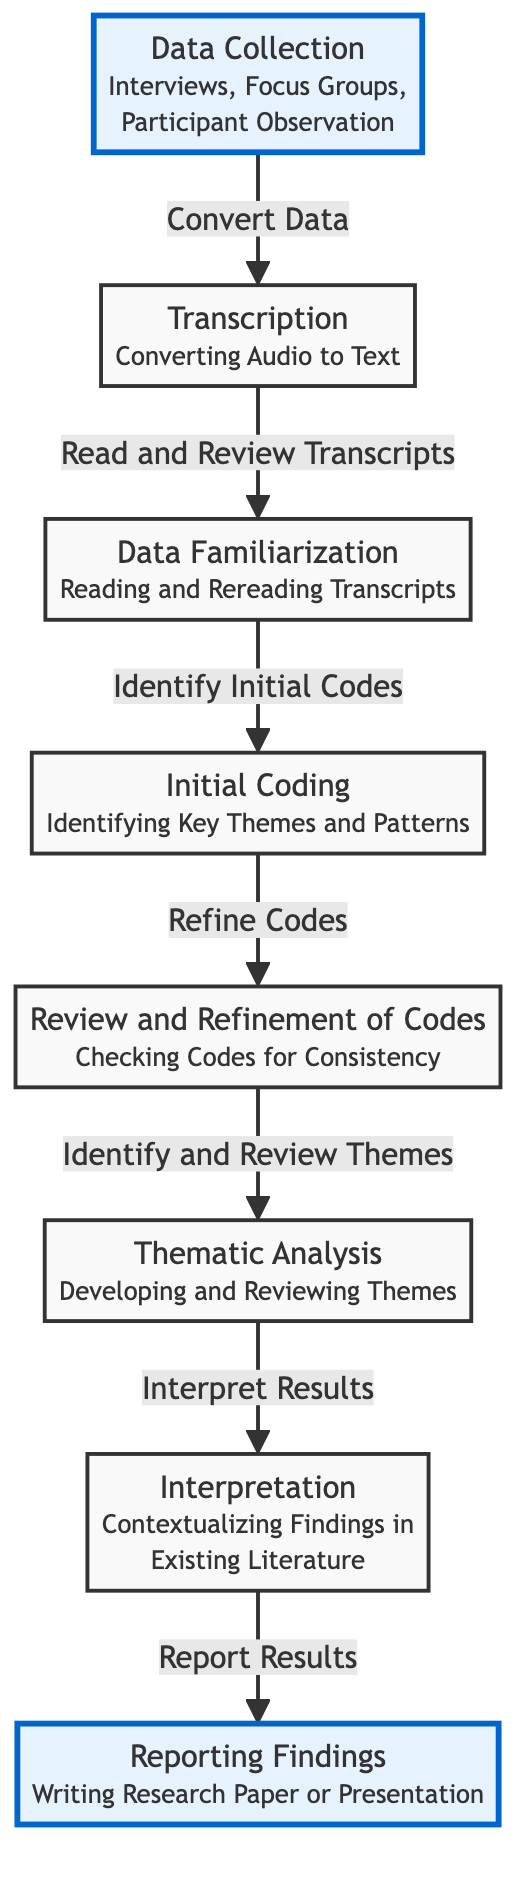What is the first step in the flow of information? The first step is "Data Collection," which includes interviews, focus groups, and participant observation. This is indicated clearly as the starting point of the diagram.
Answer: Data Collection How many nodes are in the diagram? The diagram includes a total of seven nodes, each representing a step in the qualitative research process. Counting each labeled component shows this total.
Answer: Seven Which step follows Transcription in the flow? The step that follows Transcription is "Data Familiarization," as per the directed flow indicating the order of processes in qualitative research.
Answer: Data Familiarization What action occurs after the Initial Coding step? After the Initial Coding step, the action taken is "Review and Refinement of Codes," which involves ensuring codes are consistent after initial identification.
Answer: Review and Refinement of Codes What thematic element is associated with the final step? The final step is "Reporting Findings," which involves writing a research paper or presentation that conveys the study's results. This theme encapsulates the aim of qualitative research.
Answer: Reporting Findings What step leads into Thematic Analysis? The step that leads into Thematic Analysis is "Review and Refinement of Codes," where researchers develop and review themes after refining their codes.
Answer: Review and Refinement of Codes Which steps are highlighted with an emphasis style? The steps highlighted with an emphasis style are "Data Collection" and "Reporting Findings," denoting their significance in the research process. This is visually indicated through the style applied to these nodes.
Answer: Data Collection, Reporting Findings How is the relationship between Initial Coding and Review Coding represented? The relationship is represented by a direct arrow indicating a flow from "Initial Coding" to "Review and Refinement of Codes," showing that refinement is the next logical step after initial coding.
Answer: Direct arrow (flow) What process is involved in the last step of the diagram? The process involved in the last step is "Report Results," indicating the culmination of the research process at this point, where findings are communicated effectively.
Answer: Report Results 